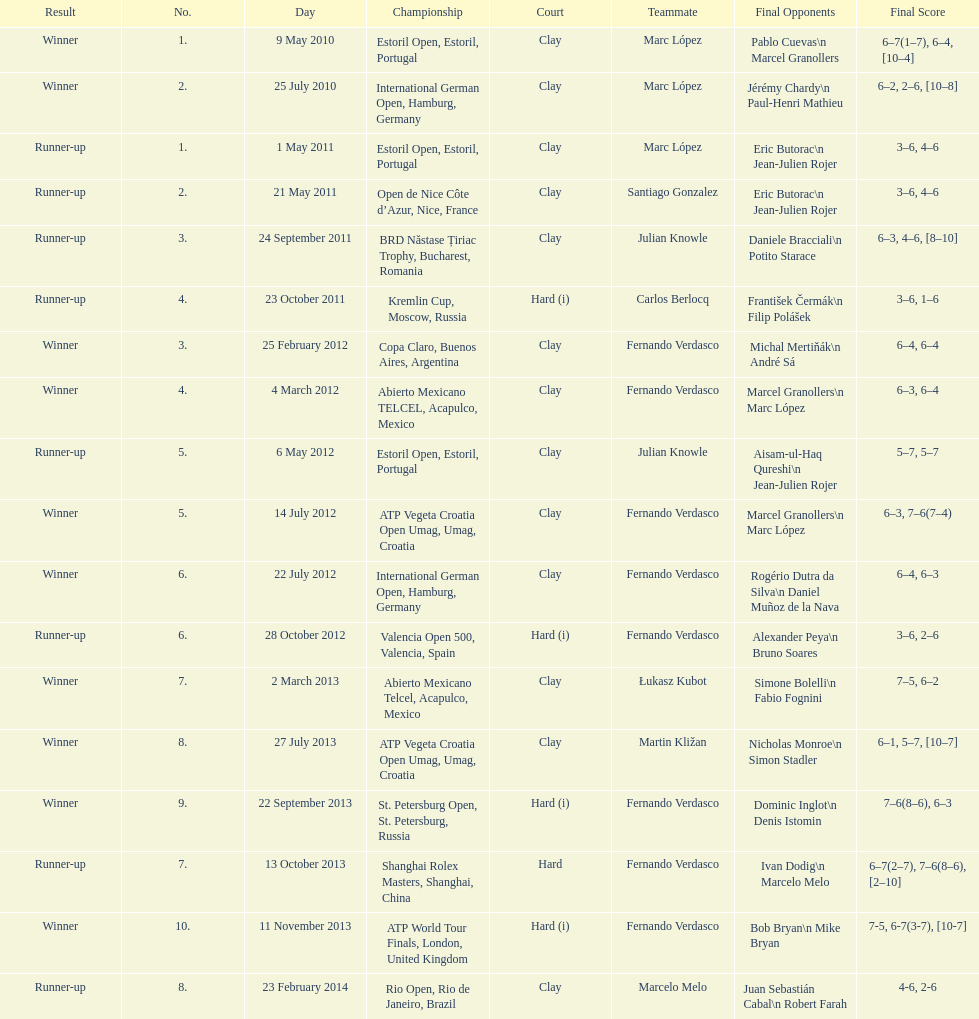What is the number of times a hard surface was used? 5. 